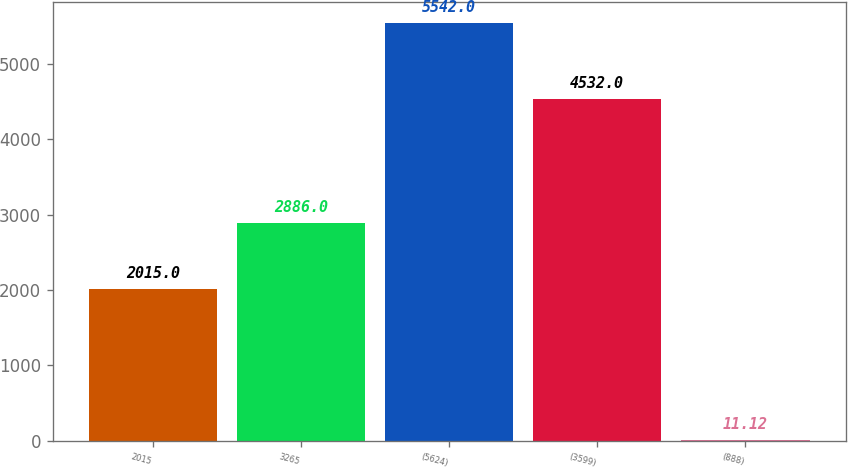<chart> <loc_0><loc_0><loc_500><loc_500><bar_chart><fcel>2015<fcel>3265<fcel>(5624)<fcel>(3599)<fcel>(888)<nl><fcel>2015<fcel>2886<fcel>5542<fcel>4532<fcel>11.12<nl></chart> 